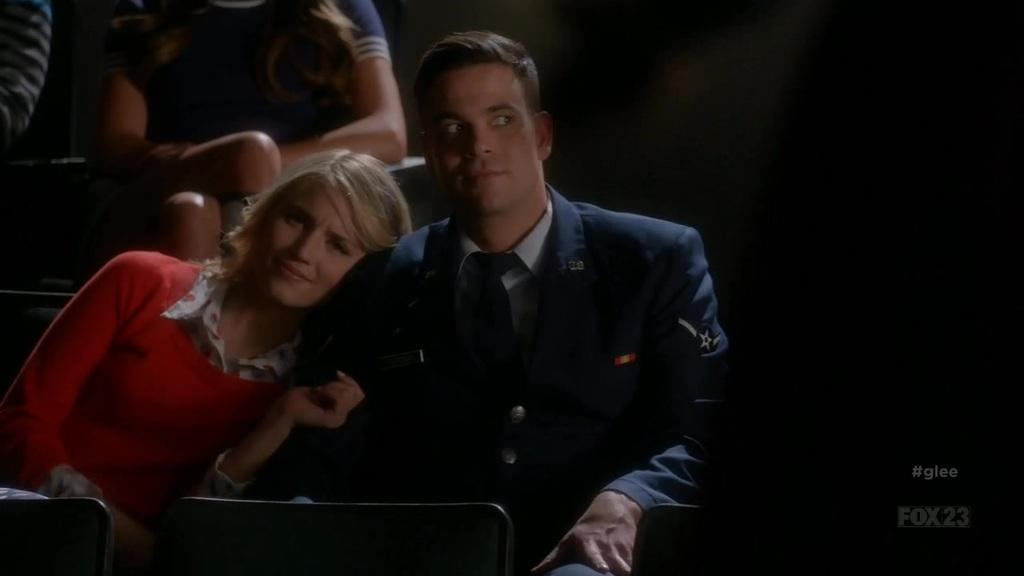What are the people in the image doing? The people in the image are sitting. What objects are present at the bottom of the image? There are chairs at the bottom of the image. What type of cord is being used by the people in the image? There is no cord present in the image; the people are simply sitting on chairs. 